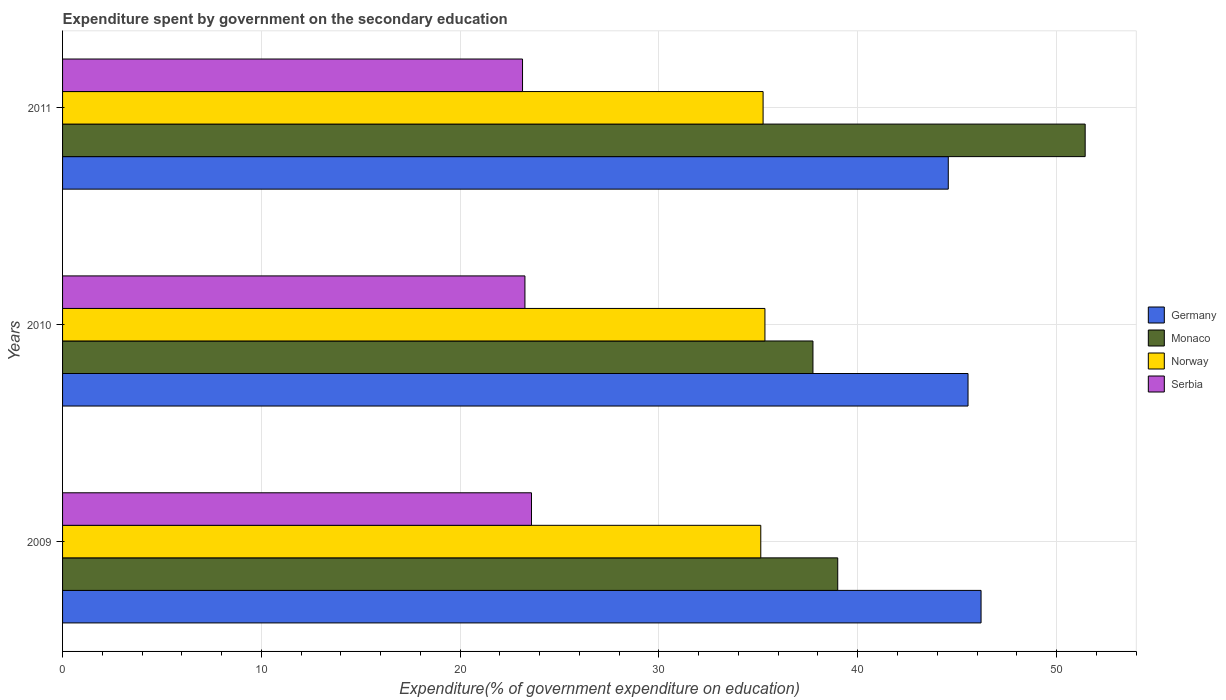How many groups of bars are there?
Offer a very short reply. 3. Are the number of bars on each tick of the Y-axis equal?
Offer a terse response. Yes. How many bars are there on the 1st tick from the top?
Offer a terse response. 4. What is the label of the 1st group of bars from the top?
Your answer should be compact. 2011. What is the expenditure spent by government on the secondary education in Serbia in 2011?
Offer a very short reply. 23.14. Across all years, what is the maximum expenditure spent by government on the secondary education in Serbia?
Offer a very short reply. 23.59. Across all years, what is the minimum expenditure spent by government on the secondary education in Norway?
Provide a succinct answer. 35.12. What is the total expenditure spent by government on the secondary education in Serbia in the graph?
Offer a very short reply. 69.98. What is the difference between the expenditure spent by government on the secondary education in Serbia in 2010 and that in 2011?
Your answer should be compact. 0.12. What is the difference between the expenditure spent by government on the secondary education in Serbia in 2009 and the expenditure spent by government on the secondary education in Monaco in 2011?
Provide a succinct answer. -27.85. What is the average expenditure spent by government on the secondary education in Monaco per year?
Offer a terse response. 42.73. In the year 2009, what is the difference between the expenditure spent by government on the secondary education in Monaco and expenditure spent by government on the secondary education in Norway?
Your answer should be very brief. 3.87. In how many years, is the expenditure spent by government on the secondary education in Monaco greater than 28 %?
Your answer should be very brief. 3. What is the ratio of the expenditure spent by government on the secondary education in Germany in 2009 to that in 2010?
Your answer should be very brief. 1.01. Is the expenditure spent by government on the secondary education in Germany in 2009 less than that in 2010?
Offer a very short reply. No. Is the difference between the expenditure spent by government on the secondary education in Monaco in 2009 and 2011 greater than the difference between the expenditure spent by government on the secondary education in Norway in 2009 and 2011?
Your answer should be very brief. No. What is the difference between the highest and the second highest expenditure spent by government on the secondary education in Germany?
Offer a very short reply. 0.66. What is the difference between the highest and the lowest expenditure spent by government on the secondary education in Germany?
Give a very brief answer. 1.65. Is it the case that in every year, the sum of the expenditure spent by government on the secondary education in Germany and expenditure spent by government on the secondary education in Norway is greater than the sum of expenditure spent by government on the secondary education in Monaco and expenditure spent by government on the secondary education in Serbia?
Keep it short and to the point. Yes. What does the 2nd bar from the bottom in 2010 represents?
Offer a very short reply. Monaco. Is it the case that in every year, the sum of the expenditure spent by government on the secondary education in Germany and expenditure spent by government on the secondary education in Norway is greater than the expenditure spent by government on the secondary education in Serbia?
Give a very brief answer. Yes. Are all the bars in the graph horizontal?
Your response must be concise. Yes. How many years are there in the graph?
Provide a short and direct response. 3. Does the graph contain any zero values?
Provide a short and direct response. No. Where does the legend appear in the graph?
Your answer should be compact. Center right. What is the title of the graph?
Keep it short and to the point. Expenditure spent by government on the secondary education. Does "Lower middle income" appear as one of the legend labels in the graph?
Give a very brief answer. No. What is the label or title of the X-axis?
Keep it short and to the point. Expenditure(% of government expenditure on education). What is the label or title of the Y-axis?
Offer a terse response. Years. What is the Expenditure(% of government expenditure on education) of Germany in 2009?
Provide a short and direct response. 46.2. What is the Expenditure(% of government expenditure on education) in Monaco in 2009?
Offer a very short reply. 38.99. What is the Expenditure(% of government expenditure on education) of Norway in 2009?
Give a very brief answer. 35.12. What is the Expenditure(% of government expenditure on education) in Serbia in 2009?
Offer a very short reply. 23.59. What is the Expenditure(% of government expenditure on education) in Germany in 2010?
Provide a succinct answer. 45.55. What is the Expenditure(% of government expenditure on education) of Monaco in 2010?
Your answer should be very brief. 37.75. What is the Expenditure(% of government expenditure on education) in Norway in 2010?
Provide a succinct answer. 35.33. What is the Expenditure(% of government expenditure on education) of Serbia in 2010?
Give a very brief answer. 23.26. What is the Expenditure(% of government expenditure on education) in Germany in 2011?
Ensure brevity in your answer.  44.55. What is the Expenditure(% of government expenditure on education) in Monaco in 2011?
Your response must be concise. 51.44. What is the Expenditure(% of government expenditure on education) in Norway in 2011?
Make the answer very short. 35.24. What is the Expenditure(% of government expenditure on education) of Serbia in 2011?
Your answer should be compact. 23.14. Across all years, what is the maximum Expenditure(% of government expenditure on education) of Germany?
Give a very brief answer. 46.2. Across all years, what is the maximum Expenditure(% of government expenditure on education) in Monaco?
Your answer should be compact. 51.44. Across all years, what is the maximum Expenditure(% of government expenditure on education) in Norway?
Give a very brief answer. 35.33. Across all years, what is the maximum Expenditure(% of government expenditure on education) of Serbia?
Your response must be concise. 23.59. Across all years, what is the minimum Expenditure(% of government expenditure on education) of Germany?
Keep it short and to the point. 44.55. Across all years, what is the minimum Expenditure(% of government expenditure on education) of Monaco?
Your answer should be compact. 37.75. Across all years, what is the minimum Expenditure(% of government expenditure on education) in Norway?
Provide a succinct answer. 35.12. Across all years, what is the minimum Expenditure(% of government expenditure on education) in Serbia?
Give a very brief answer. 23.14. What is the total Expenditure(% of government expenditure on education) in Germany in the graph?
Provide a short and direct response. 136.3. What is the total Expenditure(% of government expenditure on education) in Monaco in the graph?
Give a very brief answer. 128.18. What is the total Expenditure(% of government expenditure on education) of Norway in the graph?
Provide a short and direct response. 105.69. What is the total Expenditure(% of government expenditure on education) in Serbia in the graph?
Your answer should be compact. 69.98. What is the difference between the Expenditure(% of government expenditure on education) in Germany in 2009 and that in 2010?
Make the answer very short. 0.66. What is the difference between the Expenditure(% of government expenditure on education) in Monaco in 2009 and that in 2010?
Keep it short and to the point. 1.25. What is the difference between the Expenditure(% of government expenditure on education) in Norway in 2009 and that in 2010?
Your answer should be very brief. -0.21. What is the difference between the Expenditure(% of government expenditure on education) of Serbia in 2009 and that in 2010?
Make the answer very short. 0.33. What is the difference between the Expenditure(% of government expenditure on education) of Germany in 2009 and that in 2011?
Provide a succinct answer. 1.65. What is the difference between the Expenditure(% of government expenditure on education) in Monaco in 2009 and that in 2011?
Give a very brief answer. -12.45. What is the difference between the Expenditure(% of government expenditure on education) in Norway in 2009 and that in 2011?
Your answer should be very brief. -0.12. What is the difference between the Expenditure(% of government expenditure on education) of Serbia in 2009 and that in 2011?
Provide a succinct answer. 0.45. What is the difference between the Expenditure(% of government expenditure on education) of Germany in 2010 and that in 2011?
Keep it short and to the point. 0.99. What is the difference between the Expenditure(% of government expenditure on education) in Monaco in 2010 and that in 2011?
Provide a succinct answer. -13.69. What is the difference between the Expenditure(% of government expenditure on education) of Norway in 2010 and that in 2011?
Your answer should be compact. 0.09. What is the difference between the Expenditure(% of government expenditure on education) of Serbia in 2010 and that in 2011?
Make the answer very short. 0.12. What is the difference between the Expenditure(% of government expenditure on education) of Germany in 2009 and the Expenditure(% of government expenditure on education) of Monaco in 2010?
Your answer should be very brief. 8.46. What is the difference between the Expenditure(% of government expenditure on education) in Germany in 2009 and the Expenditure(% of government expenditure on education) in Norway in 2010?
Ensure brevity in your answer.  10.87. What is the difference between the Expenditure(% of government expenditure on education) in Germany in 2009 and the Expenditure(% of government expenditure on education) in Serbia in 2010?
Provide a succinct answer. 22.94. What is the difference between the Expenditure(% of government expenditure on education) in Monaco in 2009 and the Expenditure(% of government expenditure on education) in Norway in 2010?
Give a very brief answer. 3.66. What is the difference between the Expenditure(% of government expenditure on education) of Monaco in 2009 and the Expenditure(% of government expenditure on education) of Serbia in 2010?
Offer a terse response. 15.73. What is the difference between the Expenditure(% of government expenditure on education) in Norway in 2009 and the Expenditure(% of government expenditure on education) in Serbia in 2010?
Your answer should be compact. 11.86. What is the difference between the Expenditure(% of government expenditure on education) in Germany in 2009 and the Expenditure(% of government expenditure on education) in Monaco in 2011?
Keep it short and to the point. -5.24. What is the difference between the Expenditure(% of government expenditure on education) in Germany in 2009 and the Expenditure(% of government expenditure on education) in Norway in 2011?
Provide a short and direct response. 10.96. What is the difference between the Expenditure(% of government expenditure on education) of Germany in 2009 and the Expenditure(% of government expenditure on education) of Serbia in 2011?
Ensure brevity in your answer.  23.06. What is the difference between the Expenditure(% of government expenditure on education) of Monaco in 2009 and the Expenditure(% of government expenditure on education) of Norway in 2011?
Offer a very short reply. 3.75. What is the difference between the Expenditure(% of government expenditure on education) of Monaco in 2009 and the Expenditure(% of government expenditure on education) of Serbia in 2011?
Ensure brevity in your answer.  15.86. What is the difference between the Expenditure(% of government expenditure on education) in Norway in 2009 and the Expenditure(% of government expenditure on education) in Serbia in 2011?
Offer a terse response. 11.98. What is the difference between the Expenditure(% of government expenditure on education) in Germany in 2010 and the Expenditure(% of government expenditure on education) in Monaco in 2011?
Keep it short and to the point. -5.89. What is the difference between the Expenditure(% of government expenditure on education) of Germany in 2010 and the Expenditure(% of government expenditure on education) of Norway in 2011?
Ensure brevity in your answer.  10.31. What is the difference between the Expenditure(% of government expenditure on education) in Germany in 2010 and the Expenditure(% of government expenditure on education) in Serbia in 2011?
Ensure brevity in your answer.  22.41. What is the difference between the Expenditure(% of government expenditure on education) in Monaco in 2010 and the Expenditure(% of government expenditure on education) in Norway in 2011?
Offer a terse response. 2.51. What is the difference between the Expenditure(% of government expenditure on education) of Monaco in 2010 and the Expenditure(% of government expenditure on education) of Serbia in 2011?
Make the answer very short. 14.61. What is the difference between the Expenditure(% of government expenditure on education) of Norway in 2010 and the Expenditure(% of government expenditure on education) of Serbia in 2011?
Keep it short and to the point. 12.19. What is the average Expenditure(% of government expenditure on education) of Germany per year?
Offer a very short reply. 45.43. What is the average Expenditure(% of government expenditure on education) in Monaco per year?
Your response must be concise. 42.73. What is the average Expenditure(% of government expenditure on education) in Norway per year?
Provide a succinct answer. 35.23. What is the average Expenditure(% of government expenditure on education) in Serbia per year?
Ensure brevity in your answer.  23.33. In the year 2009, what is the difference between the Expenditure(% of government expenditure on education) in Germany and Expenditure(% of government expenditure on education) in Monaco?
Ensure brevity in your answer.  7.21. In the year 2009, what is the difference between the Expenditure(% of government expenditure on education) in Germany and Expenditure(% of government expenditure on education) in Norway?
Give a very brief answer. 11.08. In the year 2009, what is the difference between the Expenditure(% of government expenditure on education) in Germany and Expenditure(% of government expenditure on education) in Serbia?
Offer a very short reply. 22.61. In the year 2009, what is the difference between the Expenditure(% of government expenditure on education) of Monaco and Expenditure(% of government expenditure on education) of Norway?
Your response must be concise. 3.87. In the year 2009, what is the difference between the Expenditure(% of government expenditure on education) in Monaco and Expenditure(% of government expenditure on education) in Serbia?
Make the answer very short. 15.41. In the year 2009, what is the difference between the Expenditure(% of government expenditure on education) in Norway and Expenditure(% of government expenditure on education) in Serbia?
Your answer should be very brief. 11.53. In the year 2010, what is the difference between the Expenditure(% of government expenditure on education) of Germany and Expenditure(% of government expenditure on education) of Monaco?
Provide a succinct answer. 7.8. In the year 2010, what is the difference between the Expenditure(% of government expenditure on education) of Germany and Expenditure(% of government expenditure on education) of Norway?
Provide a short and direct response. 10.22. In the year 2010, what is the difference between the Expenditure(% of government expenditure on education) of Germany and Expenditure(% of government expenditure on education) of Serbia?
Provide a short and direct response. 22.29. In the year 2010, what is the difference between the Expenditure(% of government expenditure on education) in Monaco and Expenditure(% of government expenditure on education) in Norway?
Make the answer very short. 2.42. In the year 2010, what is the difference between the Expenditure(% of government expenditure on education) in Monaco and Expenditure(% of government expenditure on education) in Serbia?
Offer a terse response. 14.49. In the year 2010, what is the difference between the Expenditure(% of government expenditure on education) of Norway and Expenditure(% of government expenditure on education) of Serbia?
Give a very brief answer. 12.07. In the year 2011, what is the difference between the Expenditure(% of government expenditure on education) of Germany and Expenditure(% of government expenditure on education) of Monaco?
Your answer should be compact. -6.89. In the year 2011, what is the difference between the Expenditure(% of government expenditure on education) in Germany and Expenditure(% of government expenditure on education) in Norway?
Make the answer very short. 9.32. In the year 2011, what is the difference between the Expenditure(% of government expenditure on education) in Germany and Expenditure(% of government expenditure on education) in Serbia?
Ensure brevity in your answer.  21.42. In the year 2011, what is the difference between the Expenditure(% of government expenditure on education) in Monaco and Expenditure(% of government expenditure on education) in Norway?
Offer a terse response. 16.2. In the year 2011, what is the difference between the Expenditure(% of government expenditure on education) of Monaco and Expenditure(% of government expenditure on education) of Serbia?
Your answer should be compact. 28.3. In the year 2011, what is the difference between the Expenditure(% of government expenditure on education) of Norway and Expenditure(% of government expenditure on education) of Serbia?
Ensure brevity in your answer.  12.1. What is the ratio of the Expenditure(% of government expenditure on education) in Germany in 2009 to that in 2010?
Provide a short and direct response. 1.01. What is the ratio of the Expenditure(% of government expenditure on education) in Monaco in 2009 to that in 2010?
Give a very brief answer. 1.03. What is the ratio of the Expenditure(% of government expenditure on education) of Serbia in 2009 to that in 2010?
Your answer should be very brief. 1.01. What is the ratio of the Expenditure(% of government expenditure on education) in Monaco in 2009 to that in 2011?
Provide a short and direct response. 0.76. What is the ratio of the Expenditure(% of government expenditure on education) of Serbia in 2009 to that in 2011?
Keep it short and to the point. 1.02. What is the ratio of the Expenditure(% of government expenditure on education) in Germany in 2010 to that in 2011?
Your response must be concise. 1.02. What is the ratio of the Expenditure(% of government expenditure on education) of Monaco in 2010 to that in 2011?
Keep it short and to the point. 0.73. What is the ratio of the Expenditure(% of government expenditure on education) of Norway in 2010 to that in 2011?
Give a very brief answer. 1. What is the ratio of the Expenditure(% of government expenditure on education) of Serbia in 2010 to that in 2011?
Your response must be concise. 1.01. What is the difference between the highest and the second highest Expenditure(% of government expenditure on education) in Germany?
Offer a very short reply. 0.66. What is the difference between the highest and the second highest Expenditure(% of government expenditure on education) in Monaco?
Ensure brevity in your answer.  12.45. What is the difference between the highest and the second highest Expenditure(% of government expenditure on education) of Norway?
Your answer should be very brief. 0.09. What is the difference between the highest and the second highest Expenditure(% of government expenditure on education) of Serbia?
Provide a short and direct response. 0.33. What is the difference between the highest and the lowest Expenditure(% of government expenditure on education) in Germany?
Offer a very short reply. 1.65. What is the difference between the highest and the lowest Expenditure(% of government expenditure on education) of Monaco?
Your answer should be compact. 13.69. What is the difference between the highest and the lowest Expenditure(% of government expenditure on education) in Norway?
Offer a terse response. 0.21. What is the difference between the highest and the lowest Expenditure(% of government expenditure on education) of Serbia?
Your answer should be compact. 0.45. 